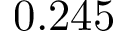Convert formula to latex. <formula><loc_0><loc_0><loc_500><loc_500>0 . 2 4 5</formula> 